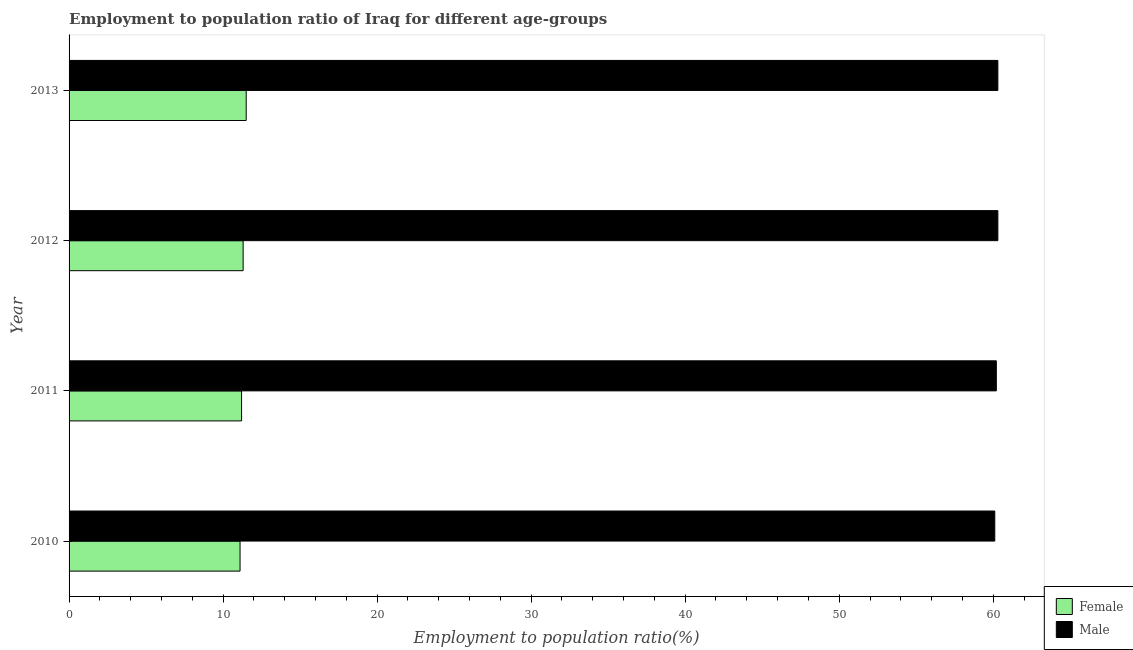Are the number of bars on each tick of the Y-axis equal?
Your answer should be very brief. Yes. How many bars are there on the 1st tick from the bottom?
Give a very brief answer. 2. What is the label of the 4th group of bars from the top?
Your answer should be compact. 2010. What is the employment to population ratio(female) in 2012?
Provide a succinct answer. 11.3. Across all years, what is the minimum employment to population ratio(female)?
Your answer should be very brief. 11.1. In which year was the employment to population ratio(female) maximum?
Offer a very short reply. 2013. In which year was the employment to population ratio(male) minimum?
Keep it short and to the point. 2010. What is the total employment to population ratio(male) in the graph?
Ensure brevity in your answer.  240.9. What is the difference between the employment to population ratio(female) in 2010 and the employment to population ratio(male) in 2013?
Your answer should be compact. -49.2. What is the average employment to population ratio(male) per year?
Offer a terse response. 60.23. Is the employment to population ratio(female) in 2012 less than that in 2013?
Make the answer very short. Yes. What is the difference between the highest and the second highest employment to population ratio(male)?
Your response must be concise. 0. What is the difference between the highest and the lowest employment to population ratio(female)?
Ensure brevity in your answer.  0.4. What does the 2nd bar from the top in 2012 represents?
Your answer should be very brief. Female. Are all the bars in the graph horizontal?
Keep it short and to the point. Yes. What is the difference between two consecutive major ticks on the X-axis?
Provide a short and direct response. 10. Does the graph contain any zero values?
Give a very brief answer. No. How many legend labels are there?
Ensure brevity in your answer.  2. How are the legend labels stacked?
Your answer should be compact. Vertical. What is the title of the graph?
Offer a terse response. Employment to population ratio of Iraq for different age-groups. What is the Employment to population ratio(%) in Female in 2010?
Provide a short and direct response. 11.1. What is the Employment to population ratio(%) of Male in 2010?
Provide a succinct answer. 60.1. What is the Employment to population ratio(%) in Female in 2011?
Make the answer very short. 11.2. What is the Employment to population ratio(%) in Male in 2011?
Your answer should be compact. 60.2. What is the Employment to population ratio(%) in Female in 2012?
Offer a terse response. 11.3. What is the Employment to population ratio(%) of Male in 2012?
Offer a terse response. 60.3. What is the Employment to population ratio(%) of Female in 2013?
Keep it short and to the point. 11.5. What is the Employment to population ratio(%) in Male in 2013?
Keep it short and to the point. 60.3. Across all years, what is the maximum Employment to population ratio(%) in Male?
Provide a succinct answer. 60.3. Across all years, what is the minimum Employment to population ratio(%) of Female?
Ensure brevity in your answer.  11.1. Across all years, what is the minimum Employment to population ratio(%) in Male?
Keep it short and to the point. 60.1. What is the total Employment to population ratio(%) in Female in the graph?
Offer a terse response. 45.1. What is the total Employment to population ratio(%) in Male in the graph?
Provide a succinct answer. 240.9. What is the difference between the Employment to population ratio(%) of Female in 2010 and that in 2011?
Your response must be concise. -0.1. What is the difference between the Employment to population ratio(%) of Male in 2010 and that in 2012?
Your answer should be very brief. -0.2. What is the difference between the Employment to population ratio(%) in Female in 2010 and that in 2013?
Keep it short and to the point. -0.4. What is the difference between the Employment to population ratio(%) in Male in 2010 and that in 2013?
Offer a very short reply. -0.2. What is the difference between the Employment to population ratio(%) in Female in 2011 and that in 2012?
Ensure brevity in your answer.  -0.1. What is the difference between the Employment to population ratio(%) in Male in 2011 and that in 2012?
Your answer should be very brief. -0.1. What is the difference between the Employment to population ratio(%) in Male in 2011 and that in 2013?
Your answer should be very brief. -0.1. What is the difference between the Employment to population ratio(%) of Female in 2012 and that in 2013?
Your response must be concise. -0.2. What is the difference between the Employment to population ratio(%) in Female in 2010 and the Employment to population ratio(%) in Male in 2011?
Ensure brevity in your answer.  -49.1. What is the difference between the Employment to population ratio(%) of Female in 2010 and the Employment to population ratio(%) of Male in 2012?
Give a very brief answer. -49.2. What is the difference between the Employment to population ratio(%) in Female in 2010 and the Employment to population ratio(%) in Male in 2013?
Provide a succinct answer. -49.2. What is the difference between the Employment to population ratio(%) of Female in 2011 and the Employment to population ratio(%) of Male in 2012?
Your answer should be very brief. -49.1. What is the difference between the Employment to population ratio(%) in Female in 2011 and the Employment to population ratio(%) in Male in 2013?
Offer a terse response. -49.1. What is the difference between the Employment to population ratio(%) in Female in 2012 and the Employment to population ratio(%) in Male in 2013?
Make the answer very short. -49. What is the average Employment to population ratio(%) of Female per year?
Offer a terse response. 11.28. What is the average Employment to population ratio(%) of Male per year?
Give a very brief answer. 60.23. In the year 2010, what is the difference between the Employment to population ratio(%) in Female and Employment to population ratio(%) in Male?
Give a very brief answer. -49. In the year 2011, what is the difference between the Employment to population ratio(%) in Female and Employment to population ratio(%) in Male?
Ensure brevity in your answer.  -49. In the year 2012, what is the difference between the Employment to population ratio(%) in Female and Employment to population ratio(%) in Male?
Your answer should be compact. -49. In the year 2013, what is the difference between the Employment to population ratio(%) of Female and Employment to population ratio(%) of Male?
Ensure brevity in your answer.  -48.8. What is the ratio of the Employment to population ratio(%) of Female in 2010 to that in 2011?
Your answer should be very brief. 0.99. What is the ratio of the Employment to population ratio(%) of Female in 2010 to that in 2012?
Give a very brief answer. 0.98. What is the ratio of the Employment to population ratio(%) of Female in 2010 to that in 2013?
Make the answer very short. 0.97. What is the ratio of the Employment to population ratio(%) of Male in 2011 to that in 2012?
Your answer should be very brief. 1. What is the ratio of the Employment to population ratio(%) in Female in 2011 to that in 2013?
Your answer should be compact. 0.97. What is the ratio of the Employment to population ratio(%) of Male in 2011 to that in 2013?
Offer a terse response. 1. What is the ratio of the Employment to population ratio(%) in Female in 2012 to that in 2013?
Give a very brief answer. 0.98. What is the difference between the highest and the second highest Employment to population ratio(%) of Female?
Offer a terse response. 0.2. What is the difference between the highest and the lowest Employment to population ratio(%) in Female?
Give a very brief answer. 0.4. What is the difference between the highest and the lowest Employment to population ratio(%) of Male?
Make the answer very short. 0.2. 